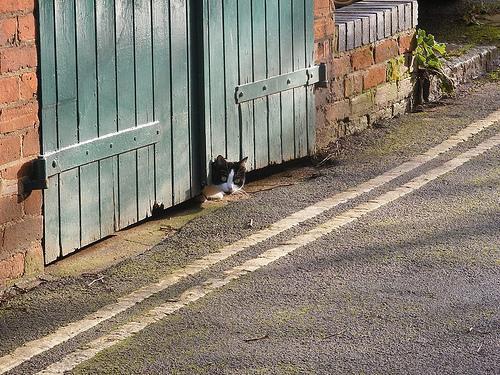How many animals are in the picture?
Give a very brief answer. 1. 